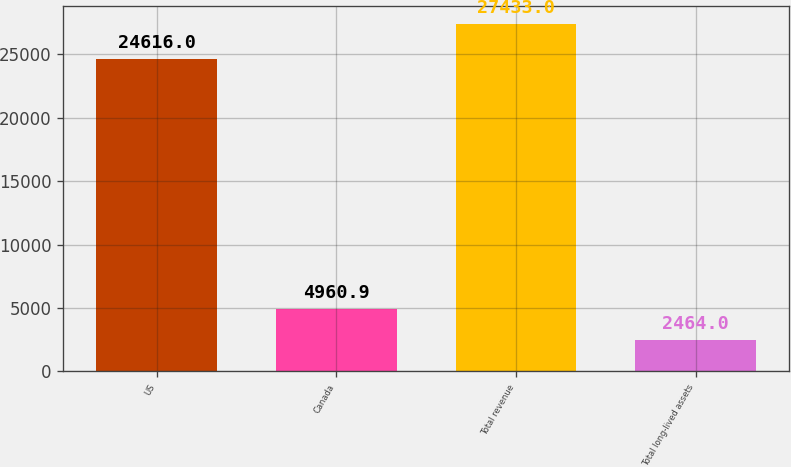<chart> <loc_0><loc_0><loc_500><loc_500><bar_chart><fcel>US<fcel>Canada<fcel>Total revenue<fcel>Total long-lived assets<nl><fcel>24616<fcel>4960.9<fcel>27433<fcel>2464<nl></chart> 